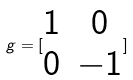<formula> <loc_0><loc_0><loc_500><loc_500>g = [ \begin{matrix} 1 & 0 \\ 0 & - 1 \end{matrix} ]</formula> 